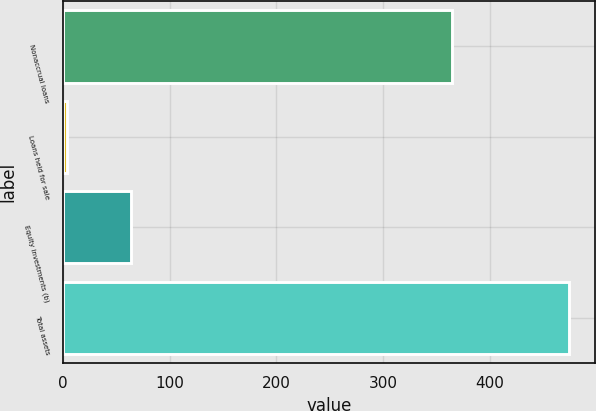Convert chart. <chart><loc_0><loc_0><loc_500><loc_500><bar_chart><fcel>Nonaccrual loans<fcel>Loans held for sale<fcel>Equity investments (b)<fcel>Total assets<nl><fcel>365<fcel>4<fcel>64<fcel>475<nl></chart> 